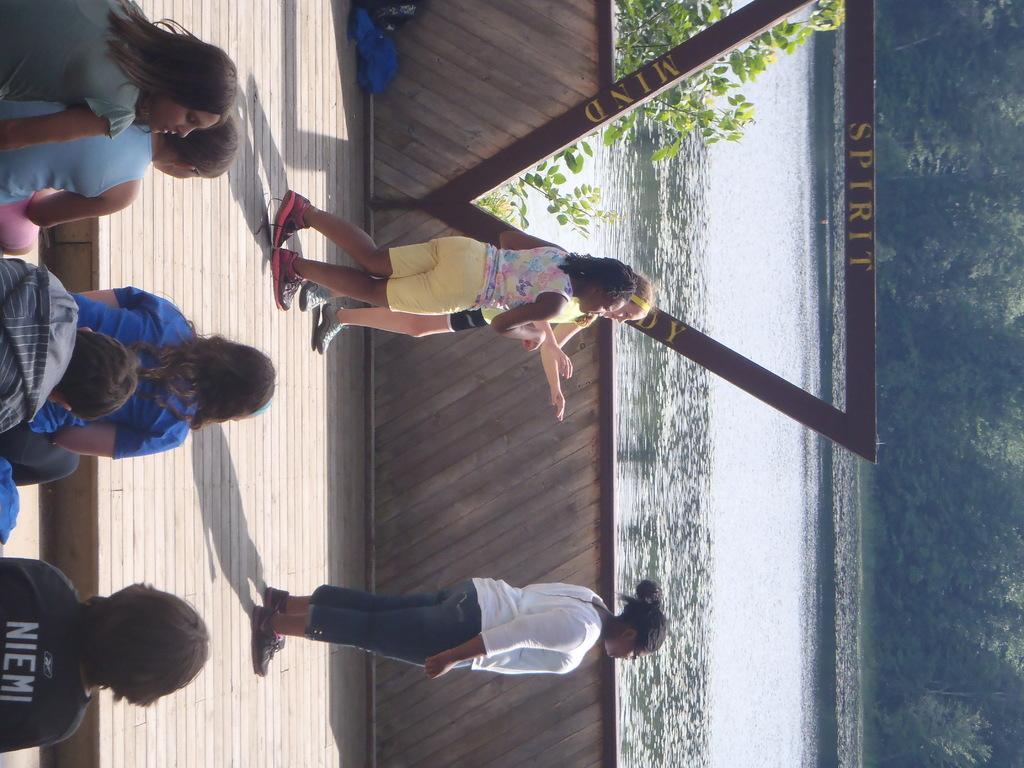In one or two sentences, can you explain what this image depicts? On the left side there are few people sitting. There are three people standing on the wooden floor. In the back there is a wall. Also there is water. And there is a triangle shape object on the wall. On that something is written. On the right side there are trees. 